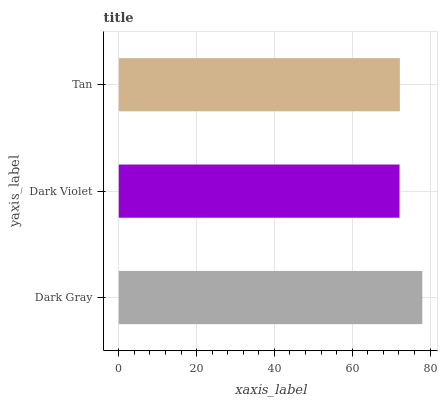Is Dark Violet the minimum?
Answer yes or no. Yes. Is Dark Gray the maximum?
Answer yes or no. Yes. Is Tan the minimum?
Answer yes or no. No. Is Tan the maximum?
Answer yes or no. No. Is Tan greater than Dark Violet?
Answer yes or no. Yes. Is Dark Violet less than Tan?
Answer yes or no. Yes. Is Dark Violet greater than Tan?
Answer yes or no. No. Is Tan less than Dark Violet?
Answer yes or no. No. Is Tan the high median?
Answer yes or no. Yes. Is Tan the low median?
Answer yes or no. Yes. Is Dark Gray the high median?
Answer yes or no. No. Is Dark Gray the low median?
Answer yes or no. No. 